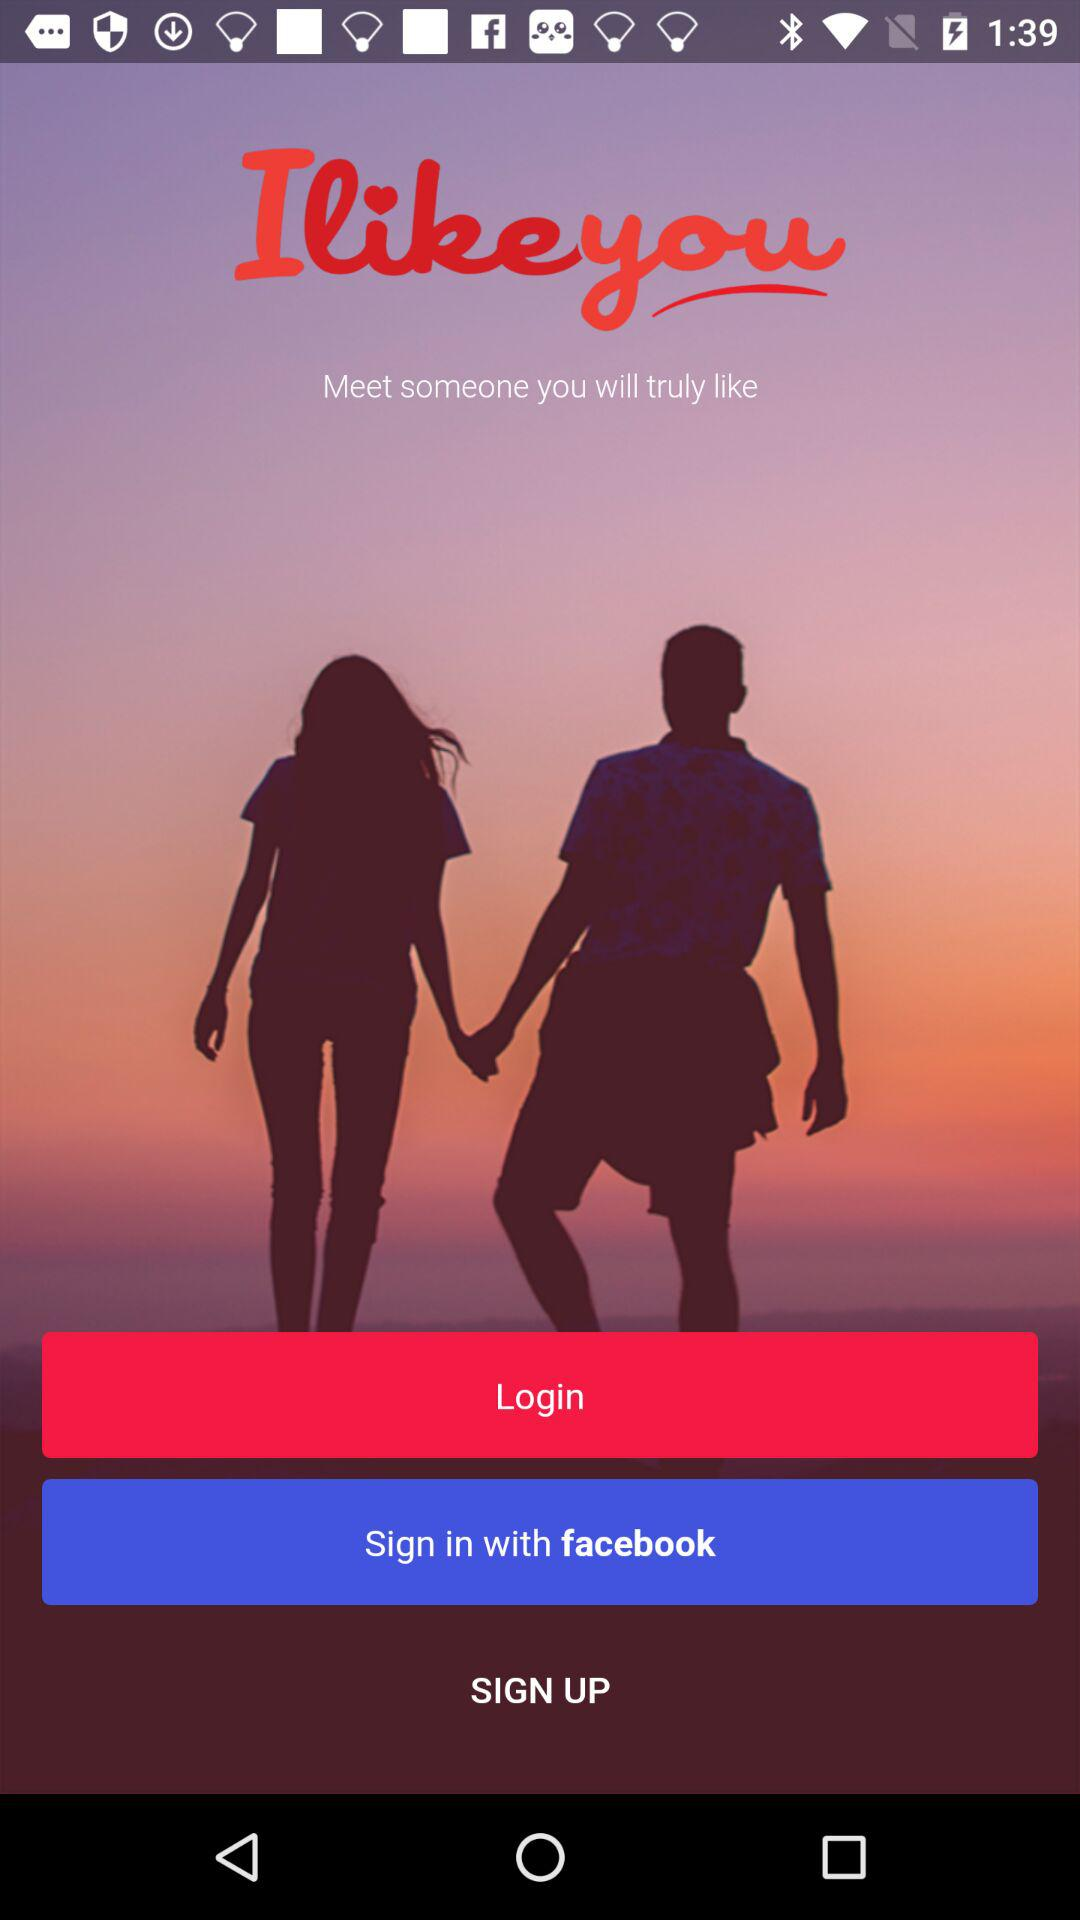What are the sign-in options? The sign-in option is "facebook". 